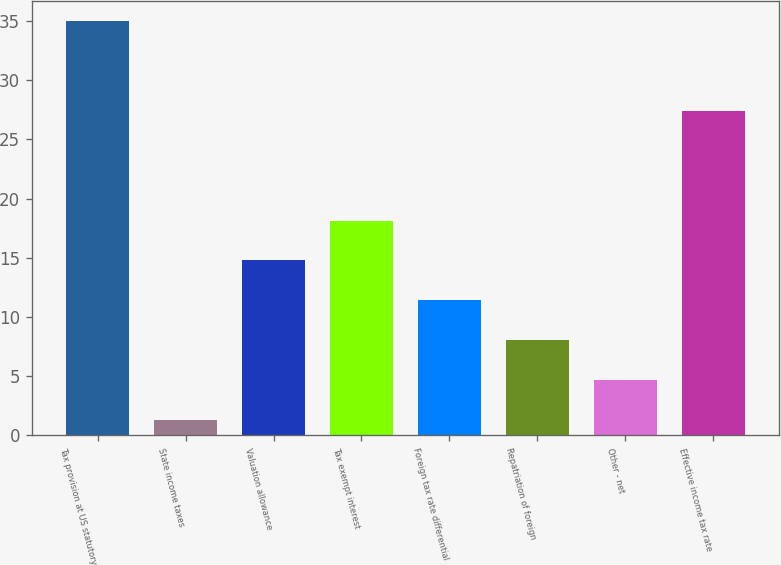Convert chart. <chart><loc_0><loc_0><loc_500><loc_500><bar_chart><fcel>Tax provision at US statutory<fcel>State income taxes<fcel>Valuation allowance<fcel>Tax exempt interest<fcel>Foreign tax rate differential<fcel>Repatriation of foreign<fcel>Other - net<fcel>Effective income tax rate<nl><fcel>35<fcel>1.3<fcel>14.78<fcel>18.15<fcel>11.41<fcel>8.04<fcel>4.67<fcel>27.4<nl></chart> 